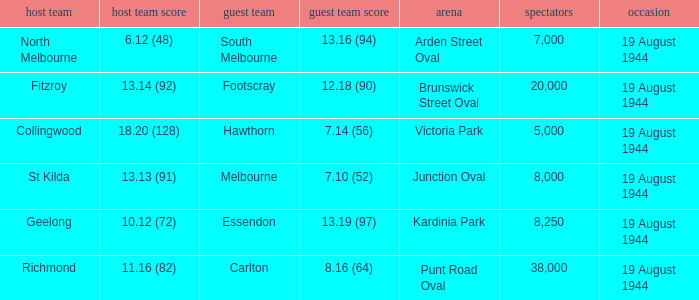What is Fitzroy's Home team score? 13.14 (92). 